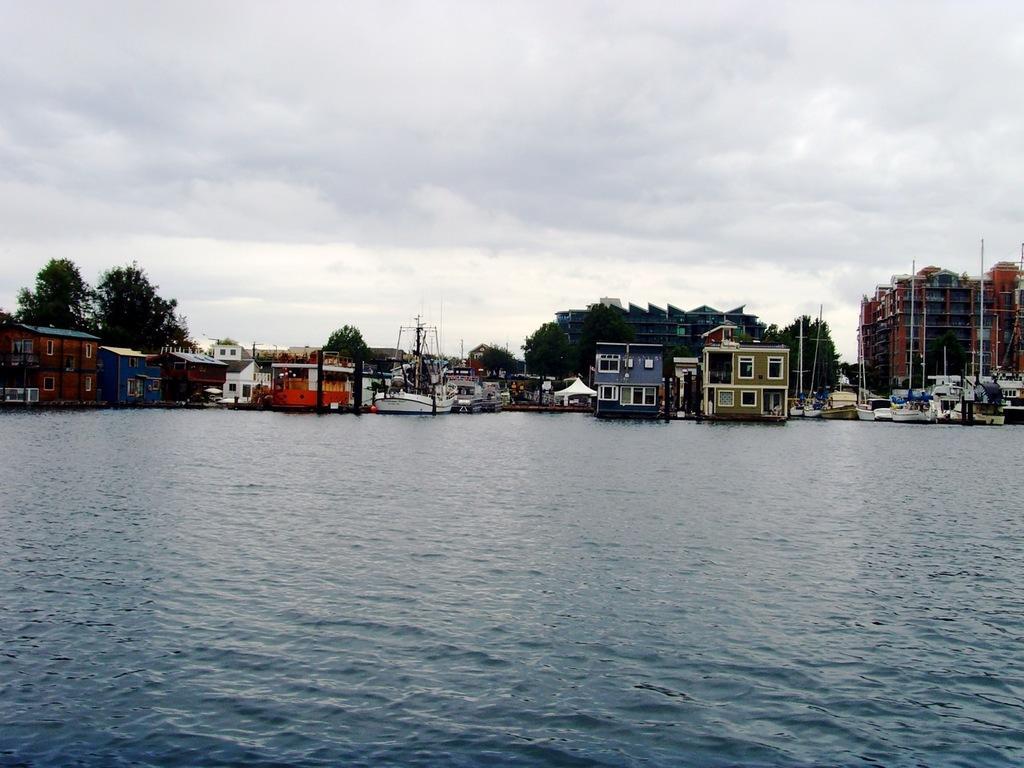Can you describe this image briefly? In this image I can see buildings and boats on the water. Here I can see poles and trees. In the background I can see the sky. 